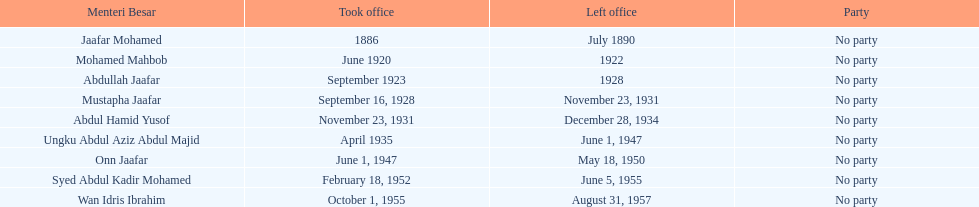Who is listed below onn jaafar? Syed Abdul Kadir Mohamed. 